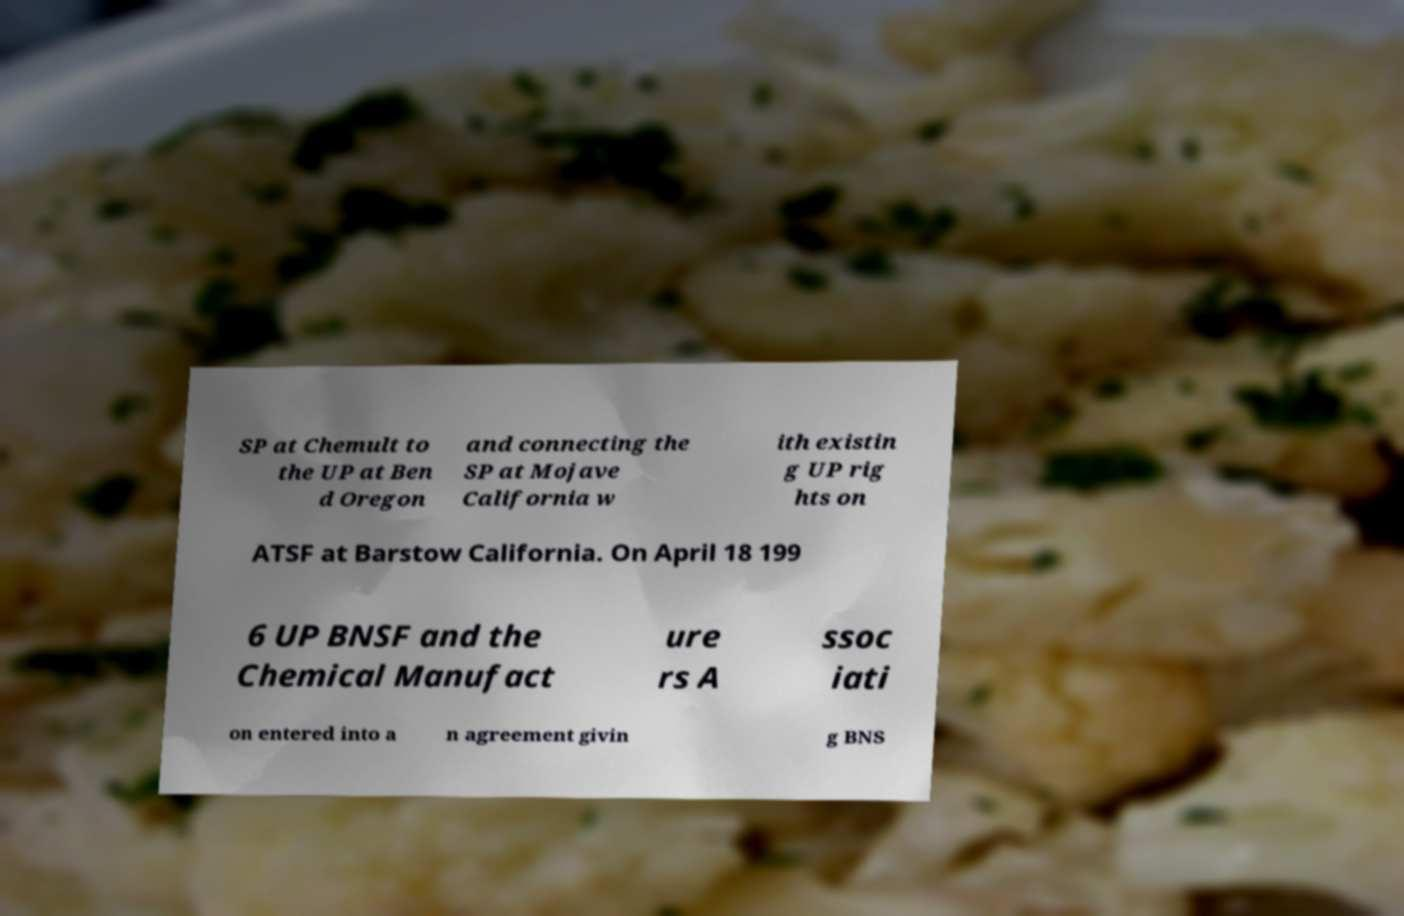Could you extract and type out the text from this image? SP at Chemult to the UP at Ben d Oregon and connecting the SP at Mojave California w ith existin g UP rig hts on ATSF at Barstow California. On April 18 199 6 UP BNSF and the Chemical Manufact ure rs A ssoc iati on entered into a n agreement givin g BNS 